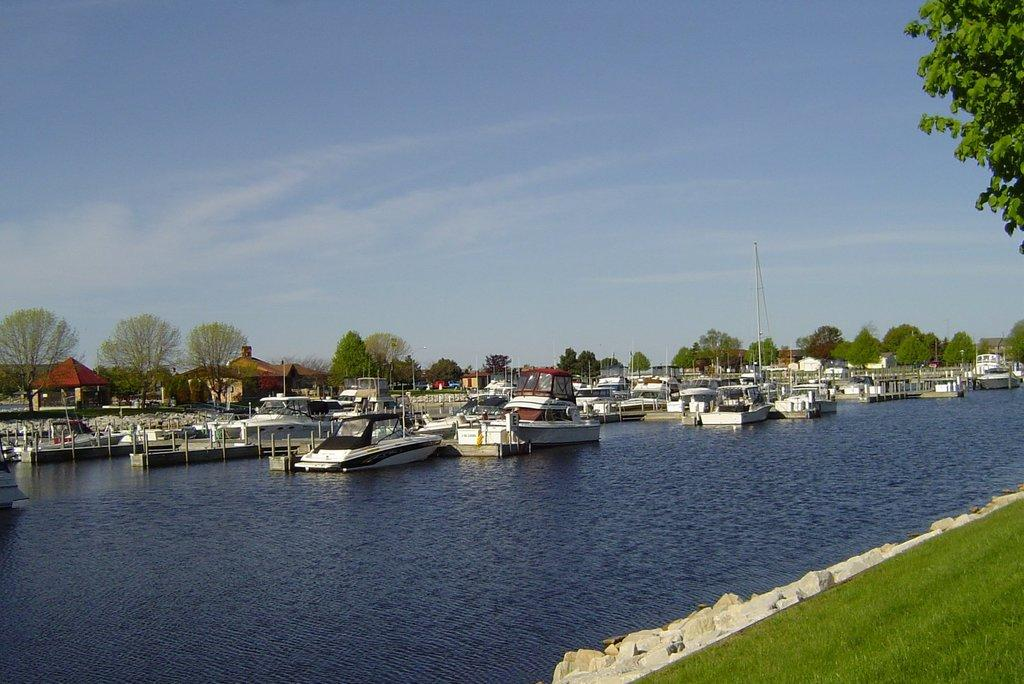What type of vehicles are in the image? There are boats in the image. What color are the boats? The boats are white in color. Where are the boats located? The boats are in water. What type of structures can be seen in the image? There are buildings in the image. What color are the buildings? The buildings are brown in color. What type of vegetation is present in the image? There are trees in the image. What color are the trees? The trees are green in color. What are the tall, thin objects in the image? There are poles in the image. What part of the natural environment is visible in the image? The sky is visible in the image. What colors can be seen in the sky? The sky is white and blue in color. Can you see a balloon floating in the sky in the image? No, there is no balloon present in the image. Is there a veil covering the trees in the image? No, there is no veil present in the image; the trees are green and visible. 